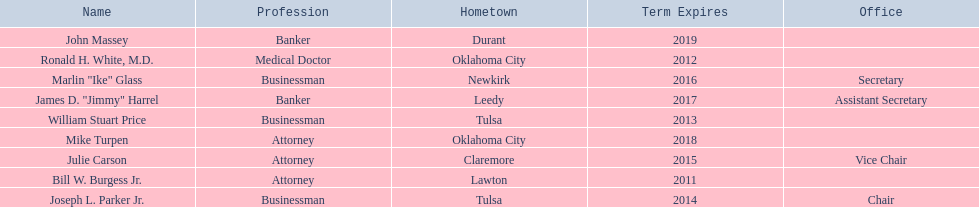How many members had businessman listed as their profession? 3. 